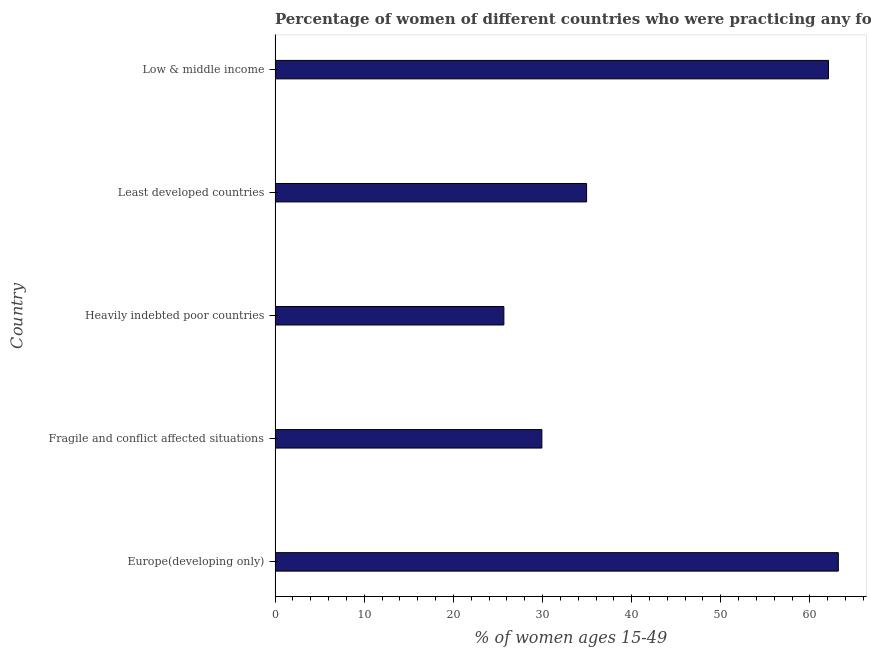Does the graph contain any zero values?
Keep it short and to the point. No. What is the title of the graph?
Ensure brevity in your answer.  Percentage of women of different countries who were practicing any form of contraception in 2011. What is the label or title of the X-axis?
Your answer should be compact. % of women ages 15-49. What is the contraceptive prevalence in Heavily indebted poor countries?
Your response must be concise. 25.66. Across all countries, what is the maximum contraceptive prevalence?
Offer a terse response. 63.18. Across all countries, what is the minimum contraceptive prevalence?
Your response must be concise. 25.66. In which country was the contraceptive prevalence maximum?
Provide a short and direct response. Europe(developing only). In which country was the contraceptive prevalence minimum?
Make the answer very short. Heavily indebted poor countries. What is the sum of the contraceptive prevalence?
Offer a very short reply. 215.8. What is the difference between the contraceptive prevalence in Least developed countries and Low & middle income?
Offer a terse response. -27.13. What is the average contraceptive prevalence per country?
Keep it short and to the point. 43.16. What is the median contraceptive prevalence?
Offer a very short reply. 34.94. What is the ratio of the contraceptive prevalence in Europe(developing only) to that in Low & middle income?
Make the answer very short. 1.02. Is the contraceptive prevalence in Europe(developing only) less than that in Least developed countries?
Provide a short and direct response. No. Is the difference between the contraceptive prevalence in Heavily indebted poor countries and Low & middle income greater than the difference between any two countries?
Your answer should be compact. No. What is the difference between the highest and the second highest contraceptive prevalence?
Make the answer very short. 1.1. Is the sum of the contraceptive prevalence in Europe(developing only) and Heavily indebted poor countries greater than the maximum contraceptive prevalence across all countries?
Keep it short and to the point. Yes. What is the difference between the highest and the lowest contraceptive prevalence?
Make the answer very short. 37.52. Are all the bars in the graph horizontal?
Offer a terse response. Yes. What is the % of women ages 15-49 of Europe(developing only)?
Keep it short and to the point. 63.18. What is the % of women ages 15-49 in Fragile and conflict affected situations?
Provide a succinct answer. 29.93. What is the % of women ages 15-49 of Heavily indebted poor countries?
Make the answer very short. 25.66. What is the % of women ages 15-49 of Least developed countries?
Provide a short and direct response. 34.94. What is the % of women ages 15-49 of Low & middle income?
Give a very brief answer. 62.08. What is the difference between the % of women ages 15-49 in Europe(developing only) and Fragile and conflict affected situations?
Provide a short and direct response. 33.26. What is the difference between the % of women ages 15-49 in Europe(developing only) and Heavily indebted poor countries?
Ensure brevity in your answer.  37.52. What is the difference between the % of women ages 15-49 in Europe(developing only) and Least developed countries?
Make the answer very short. 28.24. What is the difference between the % of women ages 15-49 in Europe(developing only) and Low & middle income?
Your answer should be very brief. 1.11. What is the difference between the % of women ages 15-49 in Fragile and conflict affected situations and Heavily indebted poor countries?
Offer a terse response. 4.26. What is the difference between the % of women ages 15-49 in Fragile and conflict affected situations and Least developed countries?
Offer a very short reply. -5.02. What is the difference between the % of women ages 15-49 in Fragile and conflict affected situations and Low & middle income?
Give a very brief answer. -32.15. What is the difference between the % of women ages 15-49 in Heavily indebted poor countries and Least developed countries?
Make the answer very short. -9.28. What is the difference between the % of women ages 15-49 in Heavily indebted poor countries and Low & middle income?
Ensure brevity in your answer.  -36.41. What is the difference between the % of women ages 15-49 in Least developed countries and Low & middle income?
Your answer should be very brief. -27.13. What is the ratio of the % of women ages 15-49 in Europe(developing only) to that in Fragile and conflict affected situations?
Your answer should be compact. 2.11. What is the ratio of the % of women ages 15-49 in Europe(developing only) to that in Heavily indebted poor countries?
Provide a succinct answer. 2.46. What is the ratio of the % of women ages 15-49 in Europe(developing only) to that in Least developed countries?
Your response must be concise. 1.81. What is the ratio of the % of women ages 15-49 in Europe(developing only) to that in Low & middle income?
Ensure brevity in your answer.  1.02. What is the ratio of the % of women ages 15-49 in Fragile and conflict affected situations to that in Heavily indebted poor countries?
Offer a terse response. 1.17. What is the ratio of the % of women ages 15-49 in Fragile and conflict affected situations to that in Least developed countries?
Keep it short and to the point. 0.86. What is the ratio of the % of women ages 15-49 in Fragile and conflict affected situations to that in Low & middle income?
Offer a terse response. 0.48. What is the ratio of the % of women ages 15-49 in Heavily indebted poor countries to that in Least developed countries?
Ensure brevity in your answer.  0.73. What is the ratio of the % of women ages 15-49 in Heavily indebted poor countries to that in Low & middle income?
Your answer should be very brief. 0.41. What is the ratio of the % of women ages 15-49 in Least developed countries to that in Low & middle income?
Keep it short and to the point. 0.56. 